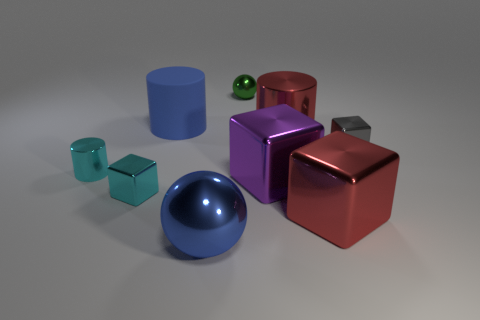What number of other large metallic cylinders have the same color as the large metallic cylinder?
Give a very brief answer. 0. Is the number of large purple objects that are to the left of the large rubber cylinder less than the number of green metal objects on the right side of the green shiny ball?
Keep it short and to the point. No. How big is the shiny cube that is right of the red block?
Your answer should be very brief. Small. What is the size of the shiny thing that is the same color as the large metallic cylinder?
Your answer should be compact. Large. Are there any big red things made of the same material as the tiny green thing?
Offer a terse response. Yes. Are the green thing and the gray cube made of the same material?
Give a very brief answer. Yes. There is a shiny block that is the same size as the gray metallic thing; what color is it?
Ensure brevity in your answer.  Cyan. How many other things are there of the same shape as the large blue matte object?
Give a very brief answer. 2. Is the size of the gray object the same as the cylinder that is on the right side of the blue metal object?
Provide a short and direct response. No. What number of things are either yellow rubber objects or shiny things?
Offer a terse response. 8. 